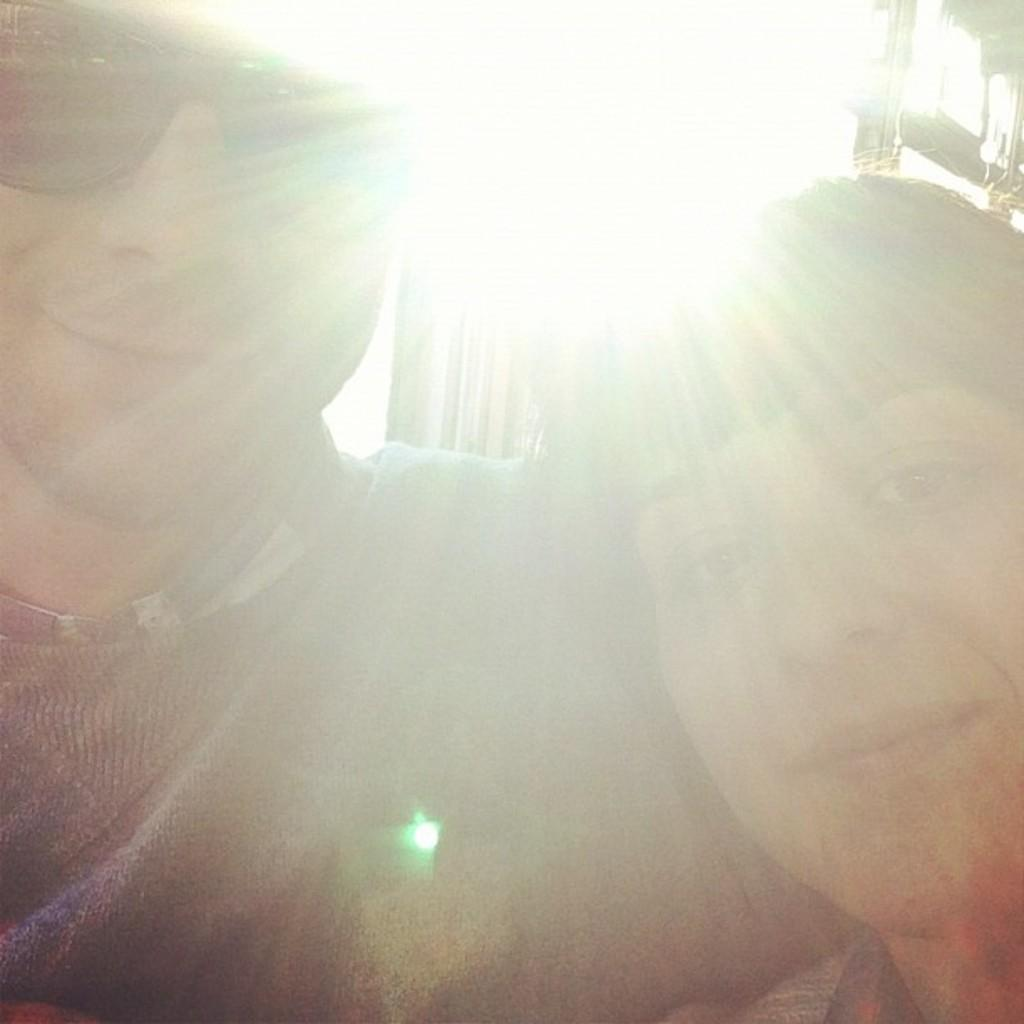How many people are present in the image? There are two people in the image. Where are the people located in the image? The people are in the front of the image. Can you describe the lighting in the image? There is light in the image. How many rabbits can be seen in the image? There are no rabbits present in the image. What type of clothing are the women wearing in the image? There is no mention of women in the provided facts, so we cannot answer this question. 